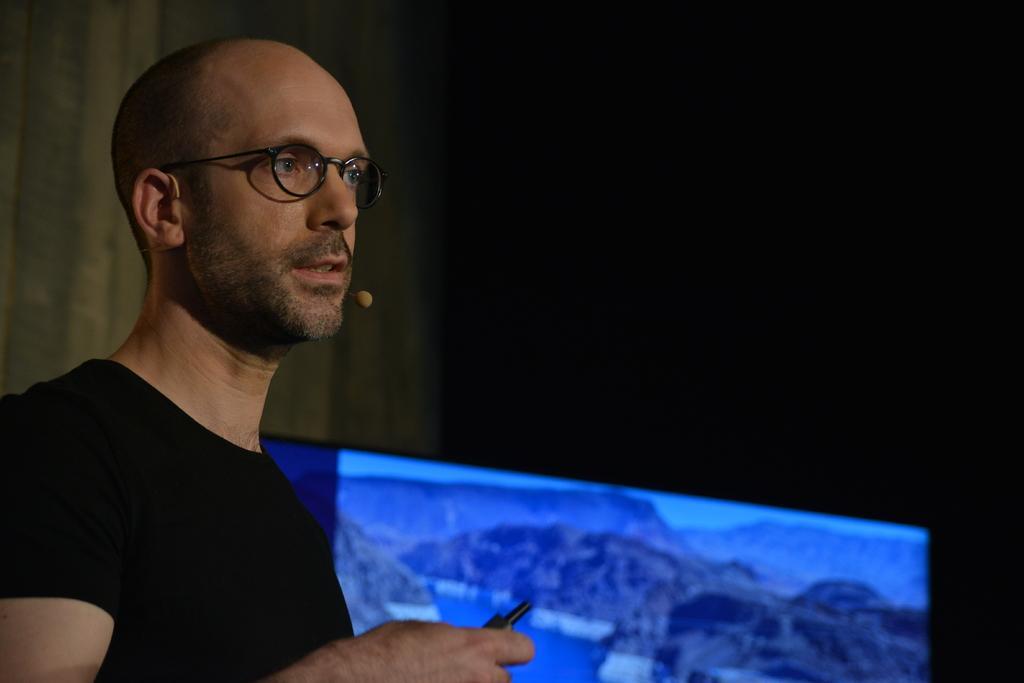Describe this image in one or two sentences. In the image I can see a person who is wearing the spectacles and holding something and to the side there is a screen. 